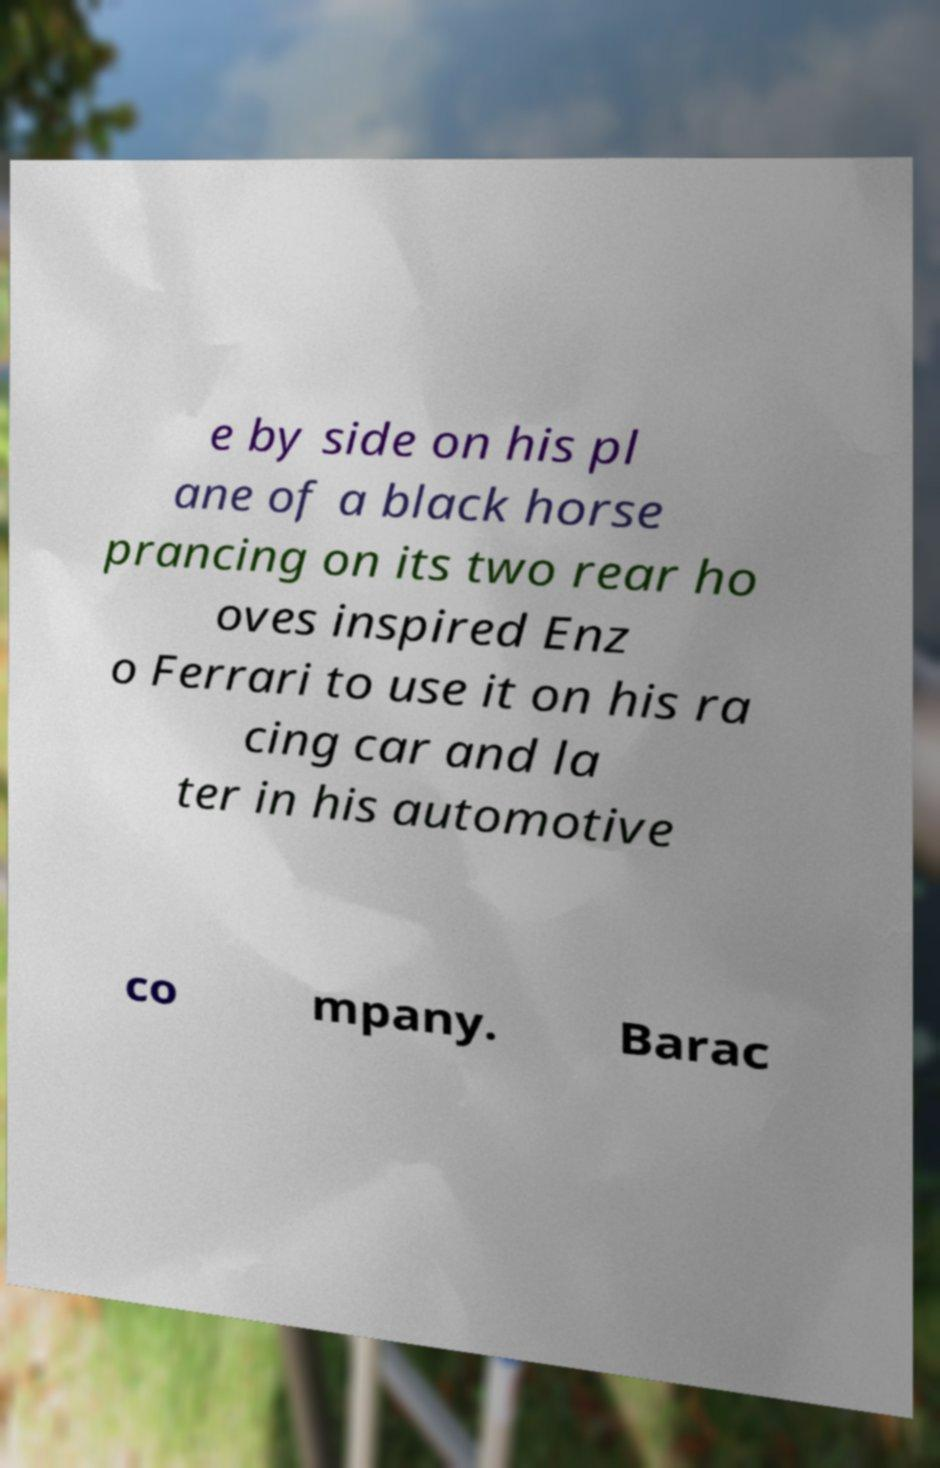What messages or text are displayed in this image? I need them in a readable, typed format. e by side on his pl ane of a black horse prancing on its two rear ho oves inspired Enz o Ferrari to use it on his ra cing car and la ter in his automotive co mpany. Barac 